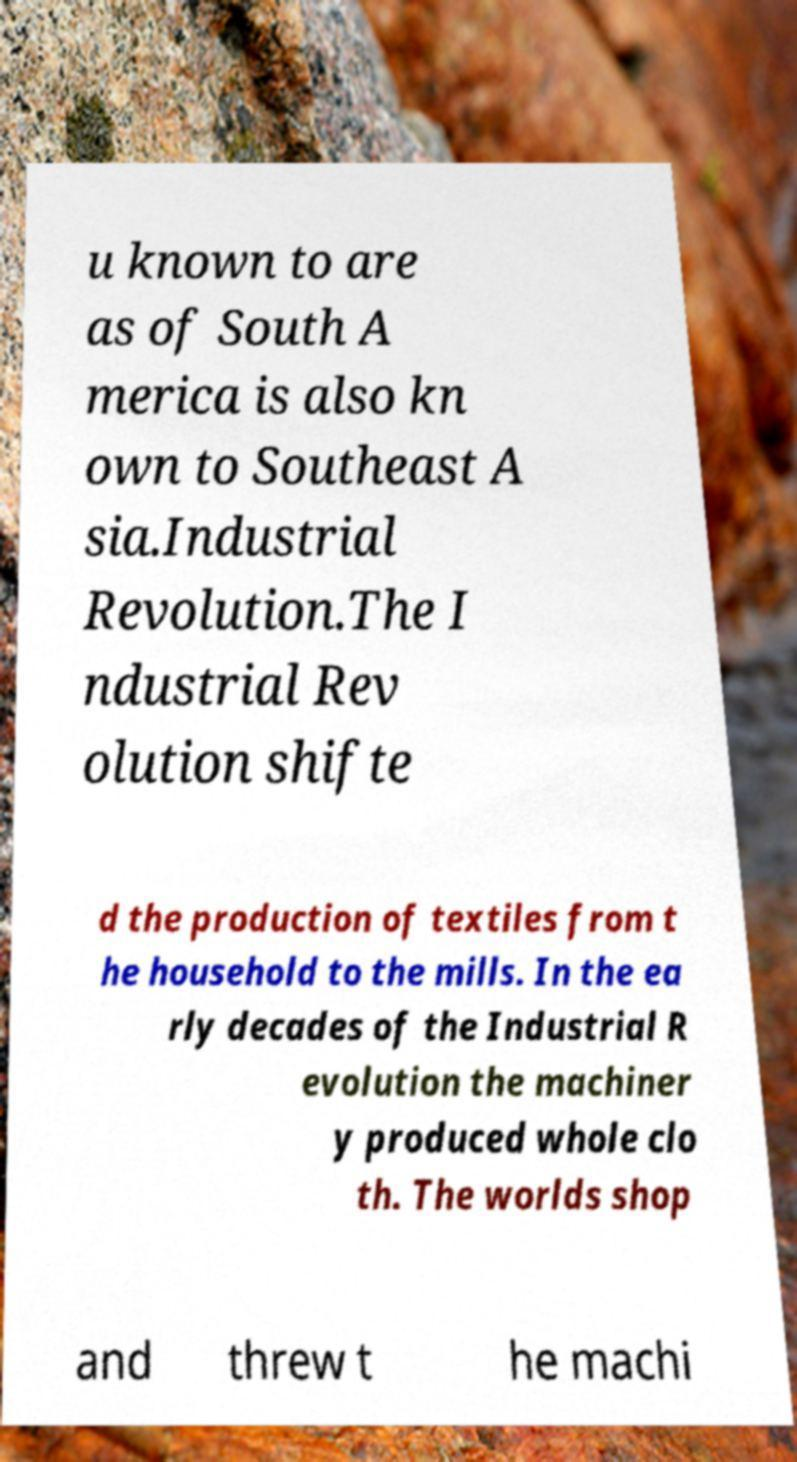Could you assist in decoding the text presented in this image and type it out clearly? u known to are as of South A merica is also kn own to Southeast A sia.Industrial Revolution.The I ndustrial Rev olution shifte d the production of textiles from t he household to the mills. In the ea rly decades of the Industrial R evolution the machiner y produced whole clo th. The worlds shop and threw t he machi 